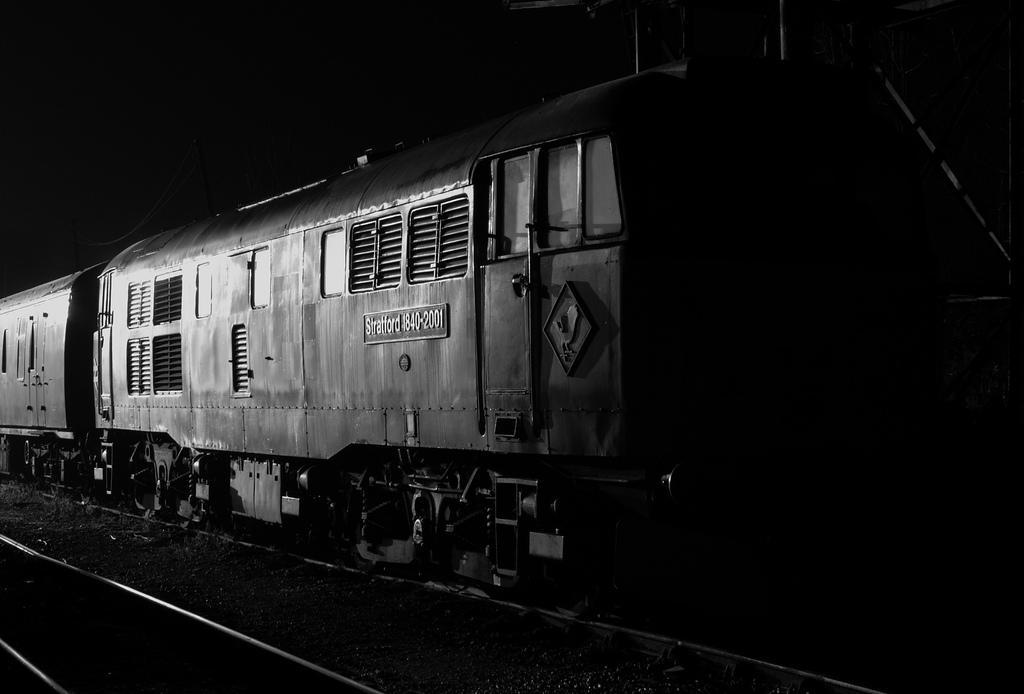Can you describe this image briefly? This image is a black and white image. This image is taken outdoors. At the bottom of the image there are railway tracks. In the middle of the image there is a train. 